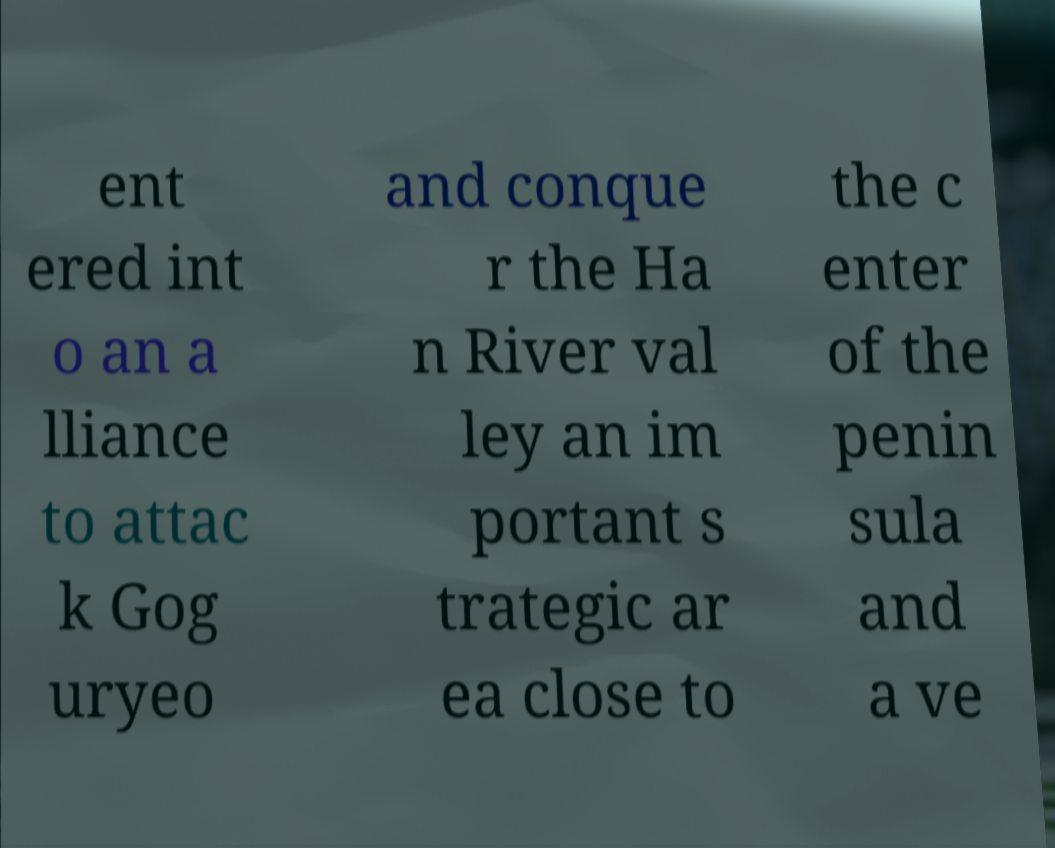I need the written content from this picture converted into text. Can you do that? ent ered int o an a lliance to attac k Gog uryeo and conque r the Ha n River val ley an im portant s trategic ar ea close to the c enter of the penin sula and a ve 